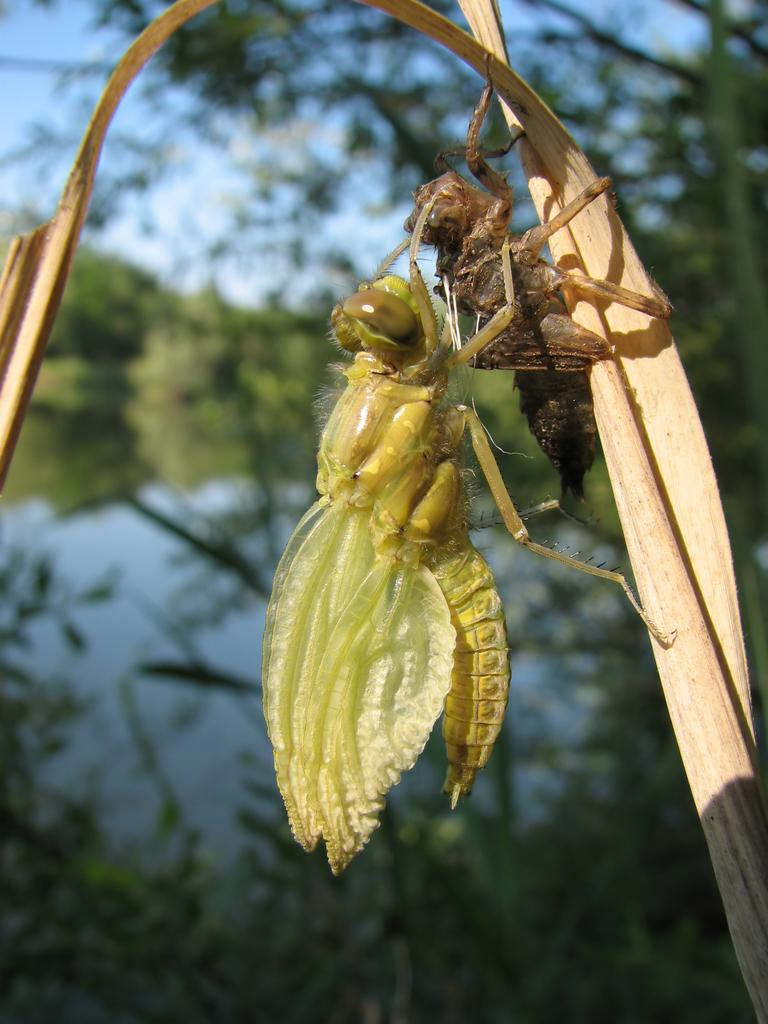How many insects are present in the image? There are 2 insects in the image. What colors can be seen on the insects? The insects are brown and green in color. Where are the insects located in the image? The insects are on an object. What colors can be seen in the background of the image? The background of the image is green and blue. What type of mask is the insect wearing in the image? There is no mask present on the insects in the image. What type of pot is the insect sitting on in the image? There is no pot present in the image; the insects are on an object, but it is not specified as a pot. 